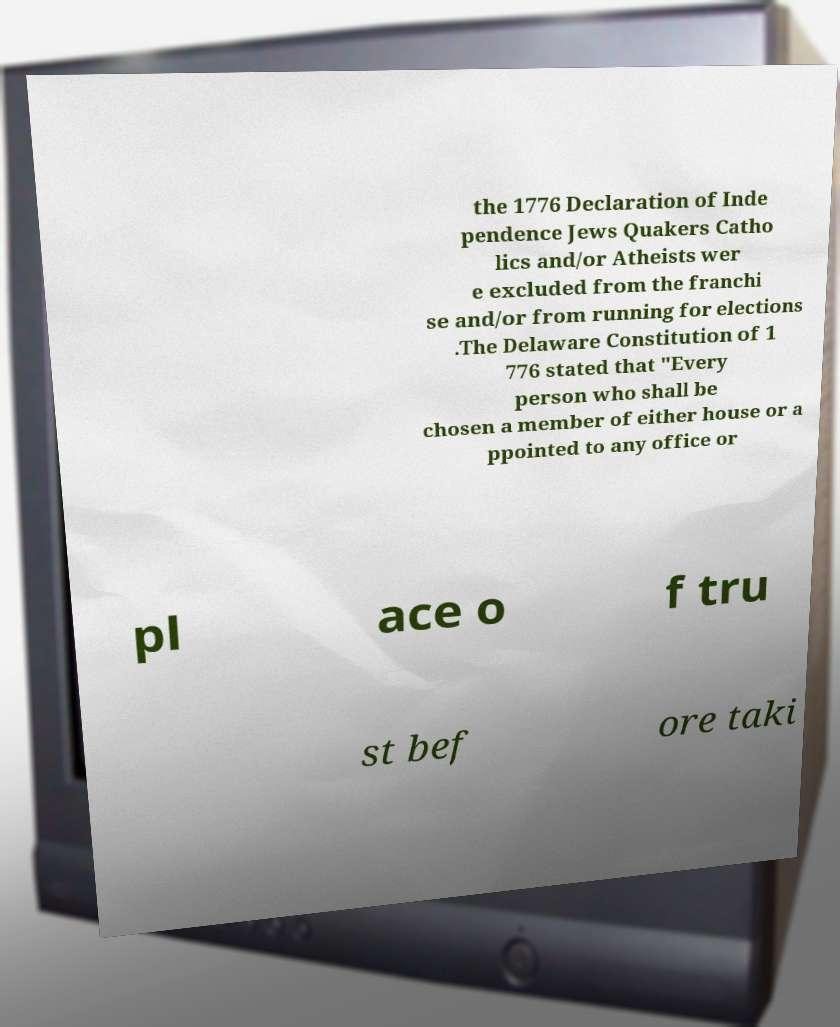Please identify and transcribe the text found in this image. the 1776 Declaration of Inde pendence Jews Quakers Catho lics and/or Atheists wer e excluded from the franchi se and/or from running for elections .The Delaware Constitution of 1 776 stated that "Every person who shall be chosen a member of either house or a ppointed to any office or pl ace o f tru st bef ore taki 